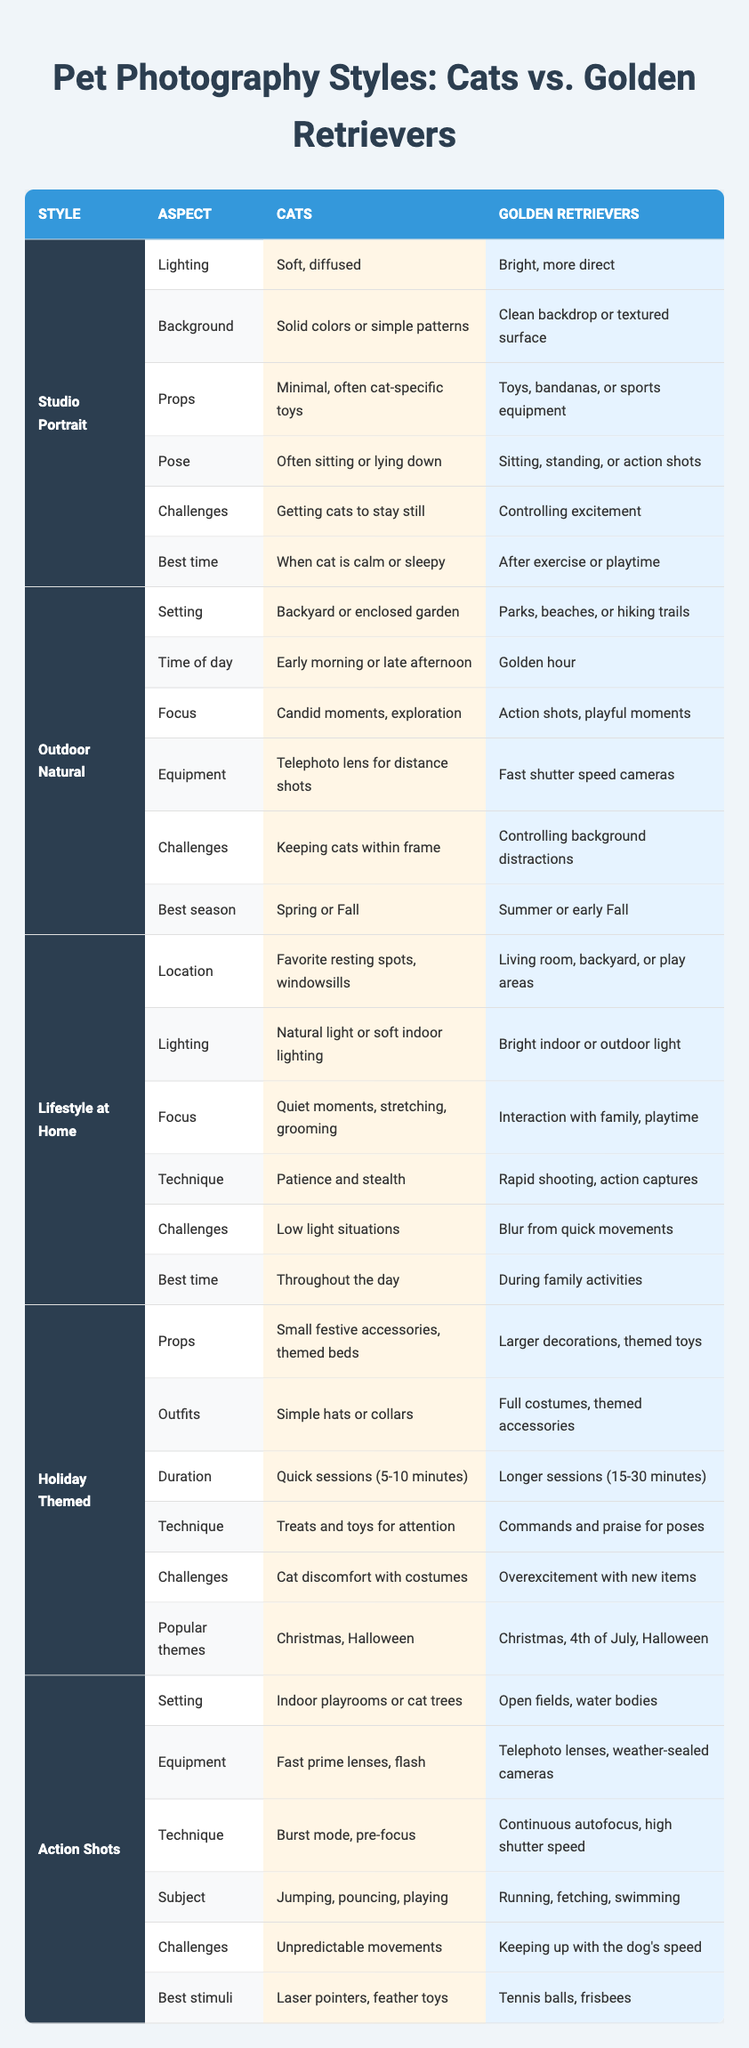What are the main challenges of taking studio portraits of cats? The table lists that the main challenge is getting cats to stay still during the photoshoot.
Answer: Getting cats to stay still Which photography style is best for capturing action shots of golden retrievers? The table shows that for golden retrievers, the Action Shots style emphasizes open fields and the use of continuous autofocus and high shutter speed to capture their movements.
Answer: Action Shots In what setting is it preferable to photograph cats outdoors? According to the table, the preferable setting for photographing cats outdoors is in a backyard or enclosed garden.
Answer: Backyard or enclosed garden True or false: The best time to take holiday-themed photographs of cats is during morning hours. The table specifies that the best time for holiday-themed photographs of cats is not specified in terms of hours, implying that quick sessions should be done at any time when the cat is cooperative.
Answer: False What are the differences in lighting between studio portrait styles for cats and golden retrievers? The lighting for cats in studio portraits is described as soft and diffused, while for golden retrievers, it is bright and more direct.
Answer: Soft, diffused for cats; bright, more direct for golden retrievers How does the duration of holiday-themed photography sessions differ between cats and golden retrievers? The table indicates that holiday-themed sessions for cats last 5-10 minutes, while for golden retrievers, they last 15-30 minutes. The difference in duration is notable.
Answer: Cats: 5-10 minutes; Golden Retrievers: 15-30 minutes What type of props are commonly used in holiday-themed photography for cats? The table lists small festive accessories and themed beds as common props for holiday-themed photography of cats.
Answer: Small festive accessories, themed beds What is a common challenge faced when photographing action shots of cats? The table states that a common challenge is their unpredictable movements, making it difficult to capture clear action shots.
Answer: Unpredictable movements Which photography style focuses on candid moments and exploration for cats? From the table, the "Outdoor Natural" style is noted for focusing on candid moments and exploration when photographing cats.
Answer: Outdoor Natural 